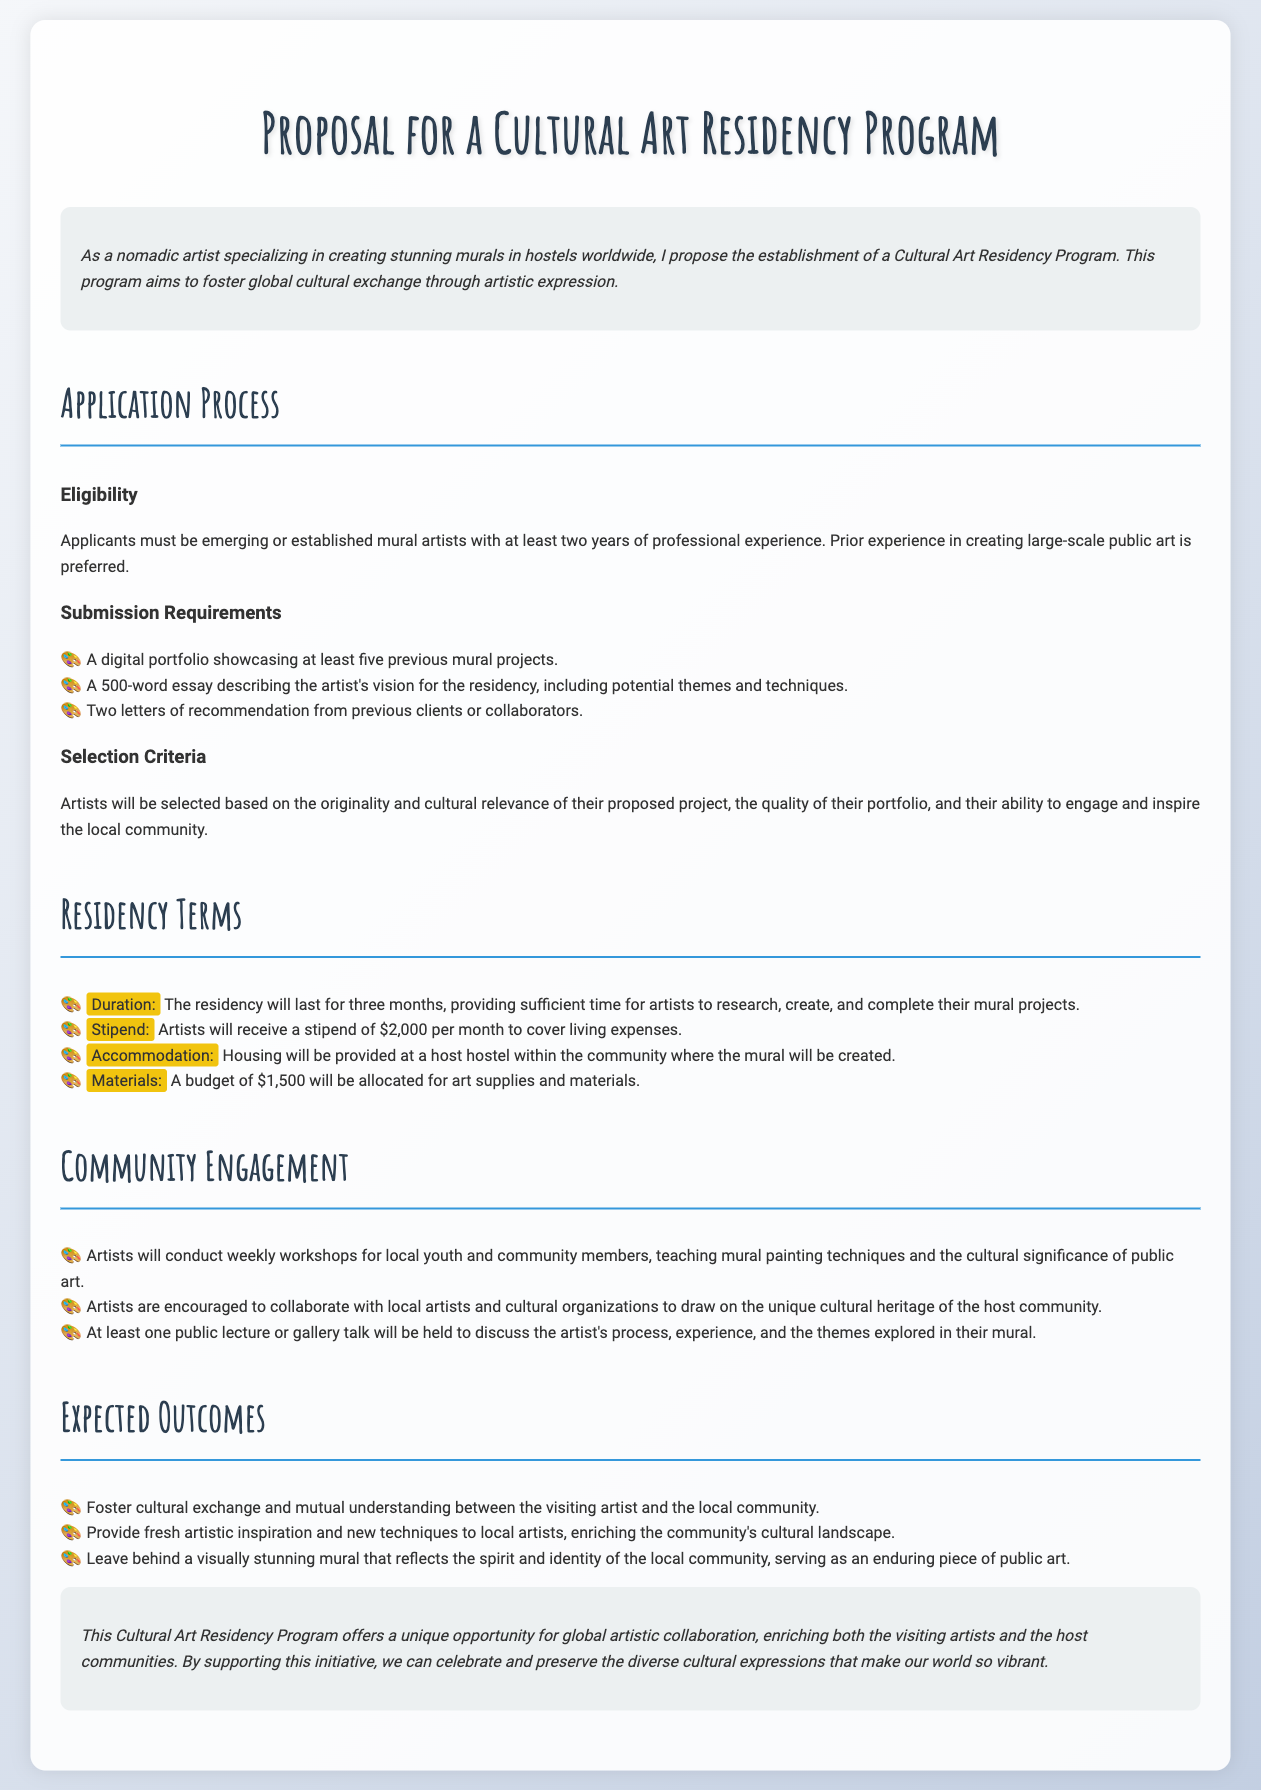What is the duration of the residency? The duration of the residency is specified in the document as three months, allowing ample time for the projects.
Answer: three months What is the stipend amount provided to artists? The stipend amount stated for artists is clearly outlined in the residency terms.
Answer: $2,000 How many letters of recommendation are required for application? The document specifies the number of letters needed in the submission requirements.
Answer: two What are artists expected to conduct weekly for the community? The expected engagement activity described in the community engagement section is essential for local interaction.
Answer: workshops What is the allocated budget for art supplies? The document provides specific financial details regarding materials in the residency terms.
Answer: $1,500 What is required in the digital portfolio submission? The requirements detail what needs to be showcased in the portfolio for applicants.
Answer: five previous mural projects What will artists leave behind as part of the residency? The expected outcome highlights the lasting contribution artists will make to the community.
Answer: a visually stunning mural How does the program aim to foster cultural exchange? The expected outcomes section describes the intention behind the connections made during the residency.
Answer: through mutual understanding What type of artists is eligible to apply? The eligibility criteria mention the specific type of artists who can apply, focusing on experience.
Answer: mural artists 